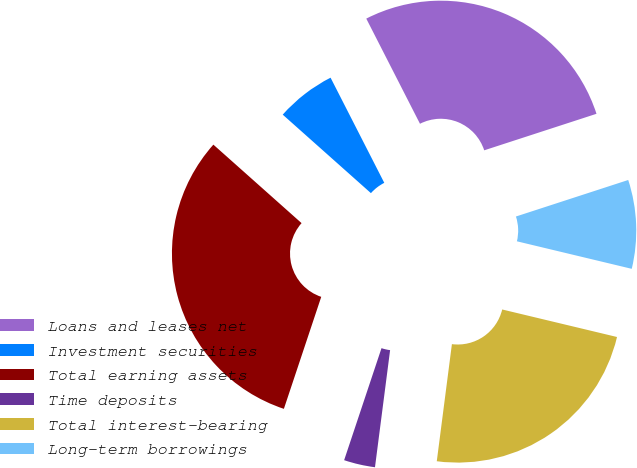Convert chart to OTSL. <chart><loc_0><loc_0><loc_500><loc_500><pie_chart><fcel>Loans and leases net<fcel>Investment securities<fcel>Total earning assets<fcel>Time deposits<fcel>Total interest-bearing<fcel>Long-term borrowings<nl><fcel>27.51%<fcel>5.91%<fcel>31.45%<fcel>3.08%<fcel>23.3%<fcel>8.75%<nl></chart> 